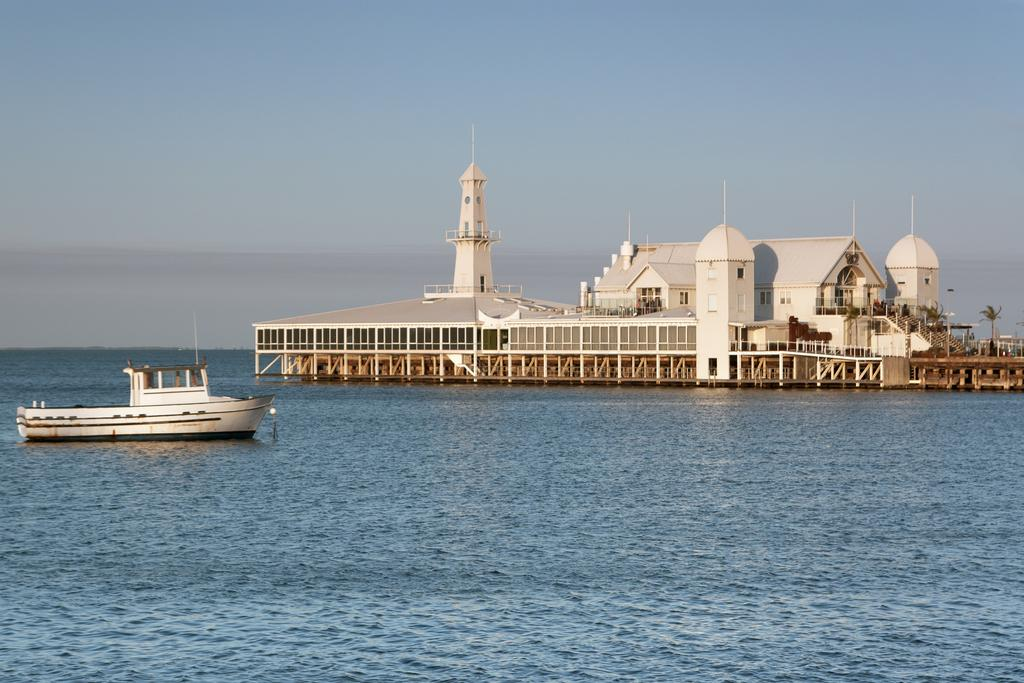What is the main subject of the image? The main subject of the image is a boat. What color is the boat? The boat is white in color. Where is the boat located in the image? The boat is on the water. What can be seen in the background of the image? There is a house in the background of the image. What color is the house? The house is white in color. What is visible above the boat and the house? The sky is visible in the image. What colors can be seen in the sky? The sky has both white and blue colors. Where is the playground located in the image? There is no playground present in the image. What type of loaf is being used as a prop in the image? There is no loaf present in the image. 